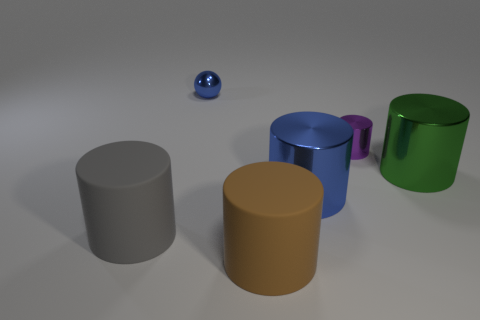How many green shiny cylinders are to the left of the large metal thing that is to the left of the big green metallic object?
Your answer should be compact. 0. What is the size of the cylinder that is both behind the gray matte thing and left of the tiny purple thing?
Make the answer very short. Large. Are there more tiny cylinders than rubber cylinders?
Make the answer very short. No. Are there any big metallic objects of the same color as the small cylinder?
Provide a short and direct response. No. Is the size of the matte thing that is behind the brown rubber object the same as the blue metallic cylinder?
Offer a very short reply. Yes. Is the number of brown spheres less than the number of small objects?
Your answer should be very brief. Yes. Are there any blue cylinders made of the same material as the small blue thing?
Your response must be concise. Yes. There is a shiny object that is on the left side of the large blue shiny object; what shape is it?
Provide a short and direct response. Sphere. Is the color of the big rubber cylinder that is in front of the gray object the same as the tiny ball?
Provide a succinct answer. No. Is the number of rubber cylinders to the right of the small sphere less than the number of small matte spheres?
Make the answer very short. No. 